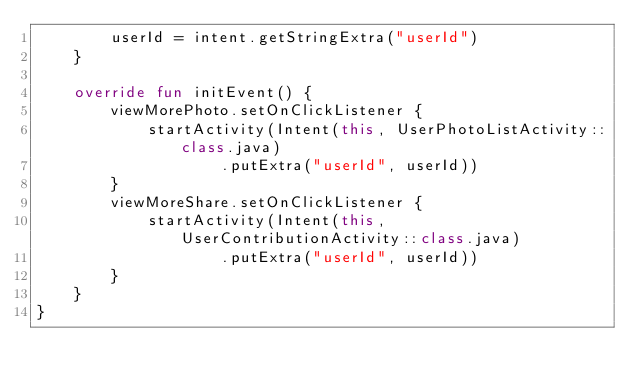Convert code to text. <code><loc_0><loc_0><loc_500><loc_500><_Kotlin_>        userId = intent.getStringExtra("userId")
    }

    override fun initEvent() {
        viewMorePhoto.setOnClickListener {
            startActivity(Intent(this, UserPhotoListActivity::class.java)
                    .putExtra("userId", userId))
        }
        viewMoreShare.setOnClickListener {
            startActivity(Intent(this, UserContributionActivity::class.java)
                    .putExtra("userId", userId))
        }
    }
}</code> 